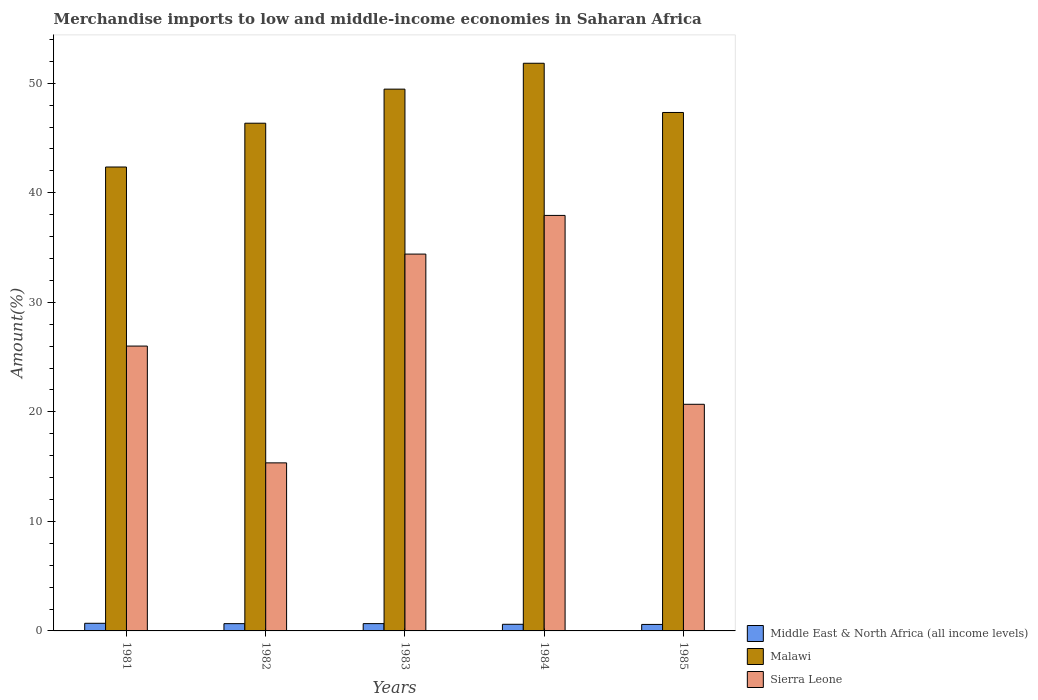How many groups of bars are there?
Give a very brief answer. 5. How many bars are there on the 5th tick from the left?
Provide a succinct answer. 3. How many bars are there on the 2nd tick from the right?
Provide a short and direct response. 3. What is the label of the 5th group of bars from the left?
Make the answer very short. 1985. What is the percentage of amount earned from merchandise imports in Sierra Leone in 1984?
Offer a terse response. 37.93. Across all years, what is the maximum percentage of amount earned from merchandise imports in Malawi?
Your response must be concise. 51.82. Across all years, what is the minimum percentage of amount earned from merchandise imports in Middle East & North Africa (all income levels)?
Keep it short and to the point. 0.59. In which year was the percentage of amount earned from merchandise imports in Sierra Leone maximum?
Your answer should be compact. 1984. What is the total percentage of amount earned from merchandise imports in Malawi in the graph?
Keep it short and to the point. 237.3. What is the difference between the percentage of amount earned from merchandise imports in Middle East & North Africa (all income levels) in 1981 and that in 1983?
Ensure brevity in your answer.  0.03. What is the difference between the percentage of amount earned from merchandise imports in Malawi in 1983 and the percentage of amount earned from merchandise imports in Middle East & North Africa (all income levels) in 1984?
Make the answer very short. 48.85. What is the average percentage of amount earned from merchandise imports in Middle East & North Africa (all income levels) per year?
Offer a terse response. 0.64. In the year 1981, what is the difference between the percentage of amount earned from merchandise imports in Middle East & North Africa (all income levels) and percentage of amount earned from merchandise imports in Sierra Leone?
Offer a very short reply. -25.31. In how many years, is the percentage of amount earned from merchandise imports in Sierra Leone greater than 8 %?
Ensure brevity in your answer.  5. What is the ratio of the percentage of amount earned from merchandise imports in Sierra Leone in 1982 to that in 1984?
Your answer should be very brief. 0.4. What is the difference between the highest and the second highest percentage of amount earned from merchandise imports in Middle East & North Africa (all income levels)?
Your answer should be compact. 0.03. What is the difference between the highest and the lowest percentage of amount earned from merchandise imports in Malawi?
Your answer should be very brief. 9.47. Is the sum of the percentage of amount earned from merchandise imports in Middle East & North Africa (all income levels) in 1982 and 1983 greater than the maximum percentage of amount earned from merchandise imports in Malawi across all years?
Offer a very short reply. No. What does the 1st bar from the left in 1982 represents?
Provide a succinct answer. Middle East & North Africa (all income levels). What does the 3rd bar from the right in 1981 represents?
Offer a terse response. Middle East & North Africa (all income levels). What is the difference between two consecutive major ticks on the Y-axis?
Keep it short and to the point. 10. Are the values on the major ticks of Y-axis written in scientific E-notation?
Your answer should be very brief. No. Does the graph contain any zero values?
Offer a very short reply. No. Does the graph contain grids?
Your answer should be compact. No. Where does the legend appear in the graph?
Keep it short and to the point. Bottom right. How many legend labels are there?
Make the answer very short. 3. What is the title of the graph?
Make the answer very short. Merchandise imports to low and middle-income economies in Saharan Africa. Does "French Polynesia" appear as one of the legend labels in the graph?
Provide a short and direct response. No. What is the label or title of the Y-axis?
Ensure brevity in your answer.  Amount(%). What is the Amount(%) of Middle East & North Africa (all income levels) in 1981?
Your answer should be very brief. 0.7. What is the Amount(%) in Malawi in 1981?
Your answer should be very brief. 42.35. What is the Amount(%) in Sierra Leone in 1981?
Make the answer very short. 26. What is the Amount(%) in Middle East & North Africa (all income levels) in 1982?
Your response must be concise. 0.66. What is the Amount(%) in Malawi in 1982?
Offer a very short reply. 46.35. What is the Amount(%) of Sierra Leone in 1982?
Offer a very short reply. 15.34. What is the Amount(%) in Middle East & North Africa (all income levels) in 1983?
Provide a succinct answer. 0.67. What is the Amount(%) in Malawi in 1983?
Provide a short and direct response. 49.46. What is the Amount(%) of Sierra Leone in 1983?
Your answer should be very brief. 34.4. What is the Amount(%) of Middle East & North Africa (all income levels) in 1984?
Make the answer very short. 0.6. What is the Amount(%) of Malawi in 1984?
Give a very brief answer. 51.82. What is the Amount(%) of Sierra Leone in 1984?
Offer a very short reply. 37.93. What is the Amount(%) in Middle East & North Africa (all income levels) in 1985?
Your answer should be very brief. 0.59. What is the Amount(%) in Malawi in 1985?
Keep it short and to the point. 47.33. What is the Amount(%) in Sierra Leone in 1985?
Keep it short and to the point. 20.69. Across all years, what is the maximum Amount(%) in Middle East & North Africa (all income levels)?
Your response must be concise. 0.7. Across all years, what is the maximum Amount(%) of Malawi?
Ensure brevity in your answer.  51.82. Across all years, what is the maximum Amount(%) of Sierra Leone?
Ensure brevity in your answer.  37.93. Across all years, what is the minimum Amount(%) of Middle East & North Africa (all income levels)?
Make the answer very short. 0.59. Across all years, what is the minimum Amount(%) of Malawi?
Make the answer very short. 42.35. Across all years, what is the minimum Amount(%) in Sierra Leone?
Your answer should be compact. 15.34. What is the total Amount(%) in Middle East & North Africa (all income levels) in the graph?
Your answer should be very brief. 3.22. What is the total Amount(%) in Malawi in the graph?
Your answer should be very brief. 237.3. What is the total Amount(%) of Sierra Leone in the graph?
Offer a very short reply. 134.36. What is the difference between the Amount(%) in Middle East & North Africa (all income levels) in 1981 and that in 1982?
Ensure brevity in your answer.  0.03. What is the difference between the Amount(%) of Malawi in 1981 and that in 1982?
Provide a short and direct response. -4. What is the difference between the Amount(%) of Sierra Leone in 1981 and that in 1982?
Your answer should be very brief. 10.66. What is the difference between the Amount(%) in Middle East & North Africa (all income levels) in 1981 and that in 1983?
Ensure brevity in your answer.  0.03. What is the difference between the Amount(%) of Malawi in 1981 and that in 1983?
Provide a succinct answer. -7.11. What is the difference between the Amount(%) in Sierra Leone in 1981 and that in 1983?
Your answer should be very brief. -8.4. What is the difference between the Amount(%) of Middle East & North Africa (all income levels) in 1981 and that in 1984?
Give a very brief answer. 0.09. What is the difference between the Amount(%) in Malawi in 1981 and that in 1984?
Give a very brief answer. -9.47. What is the difference between the Amount(%) of Sierra Leone in 1981 and that in 1984?
Your answer should be compact. -11.93. What is the difference between the Amount(%) of Middle East & North Africa (all income levels) in 1981 and that in 1985?
Offer a terse response. 0.1. What is the difference between the Amount(%) of Malawi in 1981 and that in 1985?
Your response must be concise. -4.98. What is the difference between the Amount(%) of Sierra Leone in 1981 and that in 1985?
Offer a terse response. 5.32. What is the difference between the Amount(%) in Middle East & North Africa (all income levels) in 1982 and that in 1983?
Make the answer very short. -0. What is the difference between the Amount(%) of Malawi in 1982 and that in 1983?
Provide a short and direct response. -3.11. What is the difference between the Amount(%) in Sierra Leone in 1982 and that in 1983?
Give a very brief answer. -19.06. What is the difference between the Amount(%) of Middle East & North Africa (all income levels) in 1982 and that in 1984?
Keep it short and to the point. 0.06. What is the difference between the Amount(%) in Malawi in 1982 and that in 1984?
Ensure brevity in your answer.  -5.47. What is the difference between the Amount(%) of Sierra Leone in 1982 and that in 1984?
Provide a short and direct response. -22.59. What is the difference between the Amount(%) in Middle East & North Africa (all income levels) in 1982 and that in 1985?
Make the answer very short. 0.07. What is the difference between the Amount(%) in Malawi in 1982 and that in 1985?
Ensure brevity in your answer.  -0.98. What is the difference between the Amount(%) of Sierra Leone in 1982 and that in 1985?
Make the answer very short. -5.35. What is the difference between the Amount(%) in Middle East & North Africa (all income levels) in 1983 and that in 1984?
Your answer should be compact. 0.06. What is the difference between the Amount(%) in Malawi in 1983 and that in 1984?
Offer a very short reply. -2.36. What is the difference between the Amount(%) of Sierra Leone in 1983 and that in 1984?
Your answer should be very brief. -3.53. What is the difference between the Amount(%) of Middle East & North Africa (all income levels) in 1983 and that in 1985?
Your answer should be very brief. 0.07. What is the difference between the Amount(%) in Malawi in 1983 and that in 1985?
Provide a succinct answer. 2.13. What is the difference between the Amount(%) in Sierra Leone in 1983 and that in 1985?
Offer a very short reply. 13.71. What is the difference between the Amount(%) of Middle East & North Africa (all income levels) in 1984 and that in 1985?
Ensure brevity in your answer.  0.01. What is the difference between the Amount(%) of Malawi in 1984 and that in 1985?
Your response must be concise. 4.49. What is the difference between the Amount(%) in Sierra Leone in 1984 and that in 1985?
Ensure brevity in your answer.  17.24. What is the difference between the Amount(%) of Middle East & North Africa (all income levels) in 1981 and the Amount(%) of Malawi in 1982?
Your answer should be compact. -45.65. What is the difference between the Amount(%) in Middle East & North Africa (all income levels) in 1981 and the Amount(%) in Sierra Leone in 1982?
Your answer should be compact. -14.65. What is the difference between the Amount(%) in Malawi in 1981 and the Amount(%) in Sierra Leone in 1982?
Your answer should be compact. 27.01. What is the difference between the Amount(%) of Middle East & North Africa (all income levels) in 1981 and the Amount(%) of Malawi in 1983?
Ensure brevity in your answer.  -48.76. What is the difference between the Amount(%) in Middle East & North Africa (all income levels) in 1981 and the Amount(%) in Sierra Leone in 1983?
Make the answer very short. -33.7. What is the difference between the Amount(%) of Malawi in 1981 and the Amount(%) of Sierra Leone in 1983?
Your answer should be compact. 7.95. What is the difference between the Amount(%) in Middle East & North Africa (all income levels) in 1981 and the Amount(%) in Malawi in 1984?
Offer a terse response. -51.12. What is the difference between the Amount(%) of Middle East & North Africa (all income levels) in 1981 and the Amount(%) of Sierra Leone in 1984?
Offer a terse response. -37.23. What is the difference between the Amount(%) of Malawi in 1981 and the Amount(%) of Sierra Leone in 1984?
Offer a very short reply. 4.42. What is the difference between the Amount(%) in Middle East & North Africa (all income levels) in 1981 and the Amount(%) in Malawi in 1985?
Your answer should be compact. -46.63. What is the difference between the Amount(%) in Middle East & North Africa (all income levels) in 1981 and the Amount(%) in Sierra Leone in 1985?
Your answer should be compact. -19.99. What is the difference between the Amount(%) in Malawi in 1981 and the Amount(%) in Sierra Leone in 1985?
Your answer should be compact. 21.66. What is the difference between the Amount(%) of Middle East & North Africa (all income levels) in 1982 and the Amount(%) of Malawi in 1983?
Your answer should be very brief. -48.79. What is the difference between the Amount(%) in Middle East & North Africa (all income levels) in 1982 and the Amount(%) in Sierra Leone in 1983?
Give a very brief answer. -33.74. What is the difference between the Amount(%) in Malawi in 1982 and the Amount(%) in Sierra Leone in 1983?
Keep it short and to the point. 11.95. What is the difference between the Amount(%) in Middle East & North Africa (all income levels) in 1982 and the Amount(%) in Malawi in 1984?
Give a very brief answer. -51.16. What is the difference between the Amount(%) in Middle East & North Africa (all income levels) in 1982 and the Amount(%) in Sierra Leone in 1984?
Ensure brevity in your answer.  -37.27. What is the difference between the Amount(%) in Malawi in 1982 and the Amount(%) in Sierra Leone in 1984?
Your answer should be compact. 8.42. What is the difference between the Amount(%) in Middle East & North Africa (all income levels) in 1982 and the Amount(%) in Malawi in 1985?
Provide a succinct answer. -46.66. What is the difference between the Amount(%) in Middle East & North Africa (all income levels) in 1982 and the Amount(%) in Sierra Leone in 1985?
Provide a succinct answer. -20.02. What is the difference between the Amount(%) of Malawi in 1982 and the Amount(%) of Sierra Leone in 1985?
Your response must be concise. 25.66. What is the difference between the Amount(%) in Middle East & North Africa (all income levels) in 1983 and the Amount(%) in Malawi in 1984?
Offer a very short reply. -51.15. What is the difference between the Amount(%) of Middle East & North Africa (all income levels) in 1983 and the Amount(%) of Sierra Leone in 1984?
Offer a very short reply. -37.26. What is the difference between the Amount(%) in Malawi in 1983 and the Amount(%) in Sierra Leone in 1984?
Make the answer very short. 11.53. What is the difference between the Amount(%) in Middle East & North Africa (all income levels) in 1983 and the Amount(%) in Malawi in 1985?
Give a very brief answer. -46.66. What is the difference between the Amount(%) of Middle East & North Africa (all income levels) in 1983 and the Amount(%) of Sierra Leone in 1985?
Your answer should be compact. -20.02. What is the difference between the Amount(%) of Malawi in 1983 and the Amount(%) of Sierra Leone in 1985?
Your response must be concise. 28.77. What is the difference between the Amount(%) in Middle East & North Africa (all income levels) in 1984 and the Amount(%) in Malawi in 1985?
Provide a short and direct response. -46.72. What is the difference between the Amount(%) of Middle East & North Africa (all income levels) in 1984 and the Amount(%) of Sierra Leone in 1985?
Your answer should be very brief. -20.08. What is the difference between the Amount(%) in Malawi in 1984 and the Amount(%) in Sierra Leone in 1985?
Provide a succinct answer. 31.13. What is the average Amount(%) in Middle East & North Africa (all income levels) per year?
Keep it short and to the point. 0.64. What is the average Amount(%) of Malawi per year?
Your answer should be compact. 47.46. What is the average Amount(%) of Sierra Leone per year?
Offer a very short reply. 26.87. In the year 1981, what is the difference between the Amount(%) of Middle East & North Africa (all income levels) and Amount(%) of Malawi?
Your response must be concise. -41.65. In the year 1981, what is the difference between the Amount(%) in Middle East & North Africa (all income levels) and Amount(%) in Sierra Leone?
Provide a short and direct response. -25.31. In the year 1981, what is the difference between the Amount(%) of Malawi and Amount(%) of Sierra Leone?
Your answer should be very brief. 16.35. In the year 1982, what is the difference between the Amount(%) of Middle East & North Africa (all income levels) and Amount(%) of Malawi?
Make the answer very short. -45.68. In the year 1982, what is the difference between the Amount(%) of Middle East & North Africa (all income levels) and Amount(%) of Sierra Leone?
Make the answer very short. -14.68. In the year 1982, what is the difference between the Amount(%) in Malawi and Amount(%) in Sierra Leone?
Make the answer very short. 31.01. In the year 1983, what is the difference between the Amount(%) of Middle East & North Africa (all income levels) and Amount(%) of Malawi?
Keep it short and to the point. -48.79. In the year 1983, what is the difference between the Amount(%) in Middle East & North Africa (all income levels) and Amount(%) in Sierra Leone?
Give a very brief answer. -33.73. In the year 1983, what is the difference between the Amount(%) in Malawi and Amount(%) in Sierra Leone?
Keep it short and to the point. 15.06. In the year 1984, what is the difference between the Amount(%) of Middle East & North Africa (all income levels) and Amount(%) of Malawi?
Keep it short and to the point. -51.22. In the year 1984, what is the difference between the Amount(%) of Middle East & North Africa (all income levels) and Amount(%) of Sierra Leone?
Your answer should be very brief. -37.33. In the year 1984, what is the difference between the Amount(%) in Malawi and Amount(%) in Sierra Leone?
Ensure brevity in your answer.  13.89. In the year 1985, what is the difference between the Amount(%) of Middle East & North Africa (all income levels) and Amount(%) of Malawi?
Your answer should be compact. -46.73. In the year 1985, what is the difference between the Amount(%) of Middle East & North Africa (all income levels) and Amount(%) of Sierra Leone?
Your answer should be compact. -20.1. In the year 1985, what is the difference between the Amount(%) in Malawi and Amount(%) in Sierra Leone?
Ensure brevity in your answer.  26.64. What is the ratio of the Amount(%) of Middle East & North Africa (all income levels) in 1981 to that in 1982?
Provide a succinct answer. 1.05. What is the ratio of the Amount(%) in Malawi in 1981 to that in 1982?
Provide a short and direct response. 0.91. What is the ratio of the Amount(%) of Sierra Leone in 1981 to that in 1982?
Provide a succinct answer. 1.7. What is the ratio of the Amount(%) of Middle East & North Africa (all income levels) in 1981 to that in 1983?
Provide a succinct answer. 1.04. What is the ratio of the Amount(%) of Malawi in 1981 to that in 1983?
Your answer should be very brief. 0.86. What is the ratio of the Amount(%) in Sierra Leone in 1981 to that in 1983?
Provide a short and direct response. 0.76. What is the ratio of the Amount(%) of Middle East & North Africa (all income levels) in 1981 to that in 1984?
Provide a short and direct response. 1.15. What is the ratio of the Amount(%) in Malawi in 1981 to that in 1984?
Make the answer very short. 0.82. What is the ratio of the Amount(%) of Sierra Leone in 1981 to that in 1984?
Offer a terse response. 0.69. What is the ratio of the Amount(%) of Middle East & North Africa (all income levels) in 1981 to that in 1985?
Keep it short and to the point. 1.17. What is the ratio of the Amount(%) of Malawi in 1981 to that in 1985?
Provide a succinct answer. 0.89. What is the ratio of the Amount(%) of Sierra Leone in 1981 to that in 1985?
Offer a terse response. 1.26. What is the ratio of the Amount(%) in Malawi in 1982 to that in 1983?
Give a very brief answer. 0.94. What is the ratio of the Amount(%) in Sierra Leone in 1982 to that in 1983?
Your answer should be very brief. 0.45. What is the ratio of the Amount(%) of Middle East & North Africa (all income levels) in 1982 to that in 1984?
Give a very brief answer. 1.1. What is the ratio of the Amount(%) in Malawi in 1982 to that in 1984?
Keep it short and to the point. 0.89. What is the ratio of the Amount(%) in Sierra Leone in 1982 to that in 1984?
Offer a terse response. 0.4. What is the ratio of the Amount(%) of Middle East & North Africa (all income levels) in 1982 to that in 1985?
Give a very brief answer. 1.12. What is the ratio of the Amount(%) of Malawi in 1982 to that in 1985?
Make the answer very short. 0.98. What is the ratio of the Amount(%) in Sierra Leone in 1982 to that in 1985?
Offer a terse response. 0.74. What is the ratio of the Amount(%) in Middle East & North Africa (all income levels) in 1983 to that in 1984?
Provide a succinct answer. 1.1. What is the ratio of the Amount(%) of Malawi in 1983 to that in 1984?
Ensure brevity in your answer.  0.95. What is the ratio of the Amount(%) in Sierra Leone in 1983 to that in 1984?
Provide a succinct answer. 0.91. What is the ratio of the Amount(%) in Middle East & North Africa (all income levels) in 1983 to that in 1985?
Your response must be concise. 1.12. What is the ratio of the Amount(%) in Malawi in 1983 to that in 1985?
Your response must be concise. 1.04. What is the ratio of the Amount(%) in Sierra Leone in 1983 to that in 1985?
Your answer should be very brief. 1.66. What is the ratio of the Amount(%) of Middle East & North Africa (all income levels) in 1984 to that in 1985?
Make the answer very short. 1.02. What is the ratio of the Amount(%) in Malawi in 1984 to that in 1985?
Keep it short and to the point. 1.09. What is the ratio of the Amount(%) of Sierra Leone in 1984 to that in 1985?
Your response must be concise. 1.83. What is the difference between the highest and the second highest Amount(%) of Middle East & North Africa (all income levels)?
Your answer should be compact. 0.03. What is the difference between the highest and the second highest Amount(%) of Malawi?
Give a very brief answer. 2.36. What is the difference between the highest and the second highest Amount(%) in Sierra Leone?
Keep it short and to the point. 3.53. What is the difference between the highest and the lowest Amount(%) in Middle East & North Africa (all income levels)?
Offer a very short reply. 0.1. What is the difference between the highest and the lowest Amount(%) of Malawi?
Offer a terse response. 9.47. What is the difference between the highest and the lowest Amount(%) of Sierra Leone?
Offer a very short reply. 22.59. 